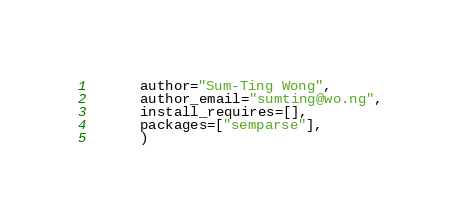<code> <loc_0><loc_0><loc_500><loc_500><_Python_>      author="Sum-Ting Wong",
      author_email="sumting@wo.ng",
      install_requires=[],
      packages=["semparse"],
      )
</code> 